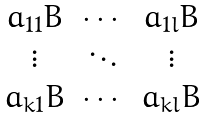<formula> <loc_0><loc_0><loc_500><loc_500>\begin{matrix} a _ { 1 1 } B & \cdots & a _ { 1 l } B \\ \vdots & \ddots & \vdots \\ a _ { k 1 } B & \cdots & a _ { k l } B \end{matrix}</formula> 